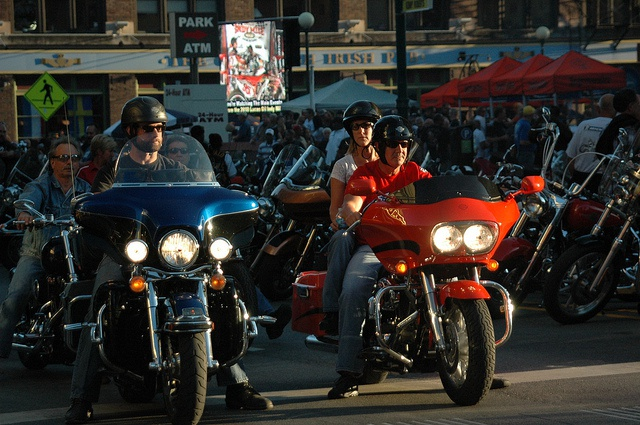Describe the objects in this image and their specific colors. I can see motorcycle in black, gray, navy, and blue tones, motorcycle in black, maroon, gray, and brown tones, people in black, purple, maroon, and gray tones, motorcycle in black, gray, and blue tones, and motorcycle in black, gray, blue, and maroon tones in this image. 